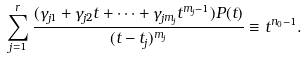Convert formula to latex. <formula><loc_0><loc_0><loc_500><loc_500>\sum _ { j = 1 } ^ { r } \frac { ( \gamma _ { j 1 } + \gamma _ { j 2 } t + \cdots + \gamma _ { j m _ { j } } t ^ { m _ { j } - 1 } ) P ( t ) } { ( t - t _ { j } ) ^ { m _ { j } } } \equiv t ^ { n _ { 0 } - 1 } .</formula> 